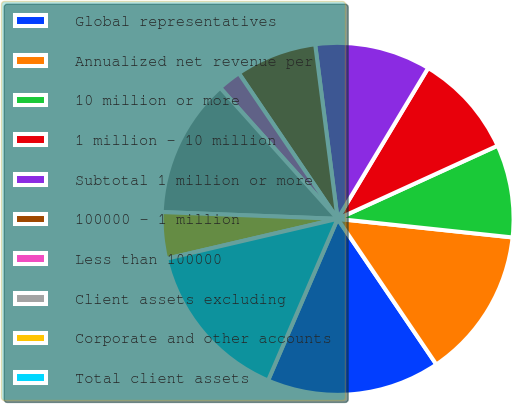Convert chart to OTSL. <chart><loc_0><loc_0><loc_500><loc_500><pie_chart><fcel>Global representatives<fcel>Annualized net revenue per<fcel>10 million or more<fcel>1 million - 10 million<fcel>Subtotal 1 million or more<fcel>100000 - 1 million<fcel>Less than 100000<fcel>Client assets excluding<fcel>Corporate and other accounts<fcel>Total client assets<nl><fcel>15.95%<fcel>13.83%<fcel>8.51%<fcel>9.57%<fcel>10.64%<fcel>7.45%<fcel>2.14%<fcel>12.76%<fcel>4.26%<fcel>14.89%<nl></chart> 